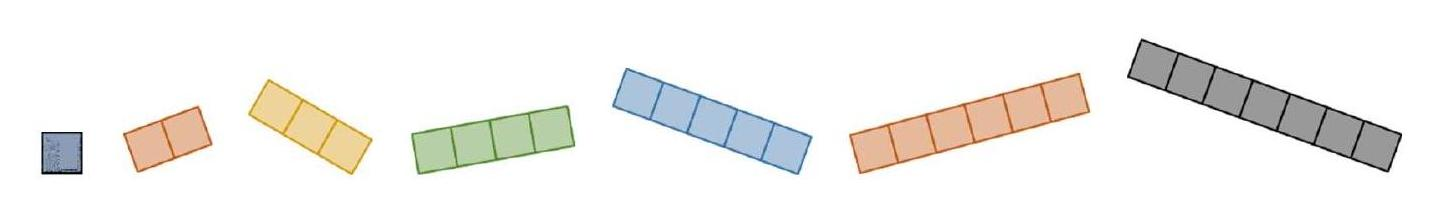Which of these pieces would fit into a 5x5 grid leaving no empty spaces? To fill a 5x5 grid perfectly without any empty spaces, using the pieces shown, you would have to use combinations of the pieces that altogether cover exactly 25 squares since each square in the grid represents one unit. Each piece must be used such that it integrates perfectly with the others, covering the entire grid evenly and without overlap. 